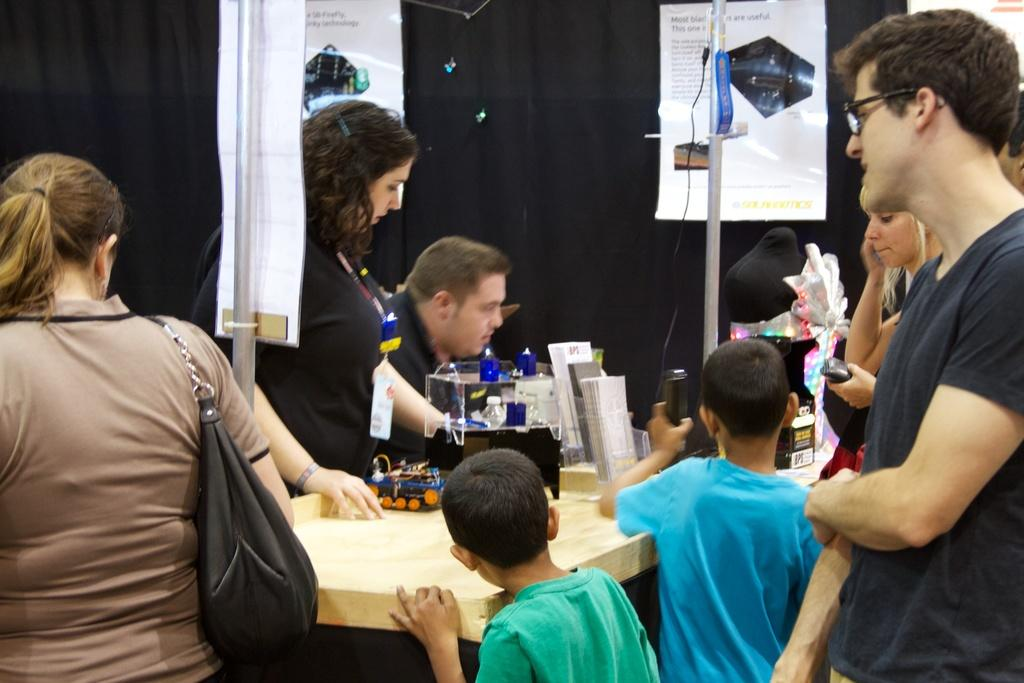Who is present in the image? There are people in the image. What is the woman holding in the image? The woman is carrying a bag. What can be seen on the table in the image? There are objects on a table. What is visible in the background of the image? There are banners and poles in the background. How does the woman balance the quartz on her nose in the image? There is no quartz present in the image, and the woman is not balancing anything on her nose. 